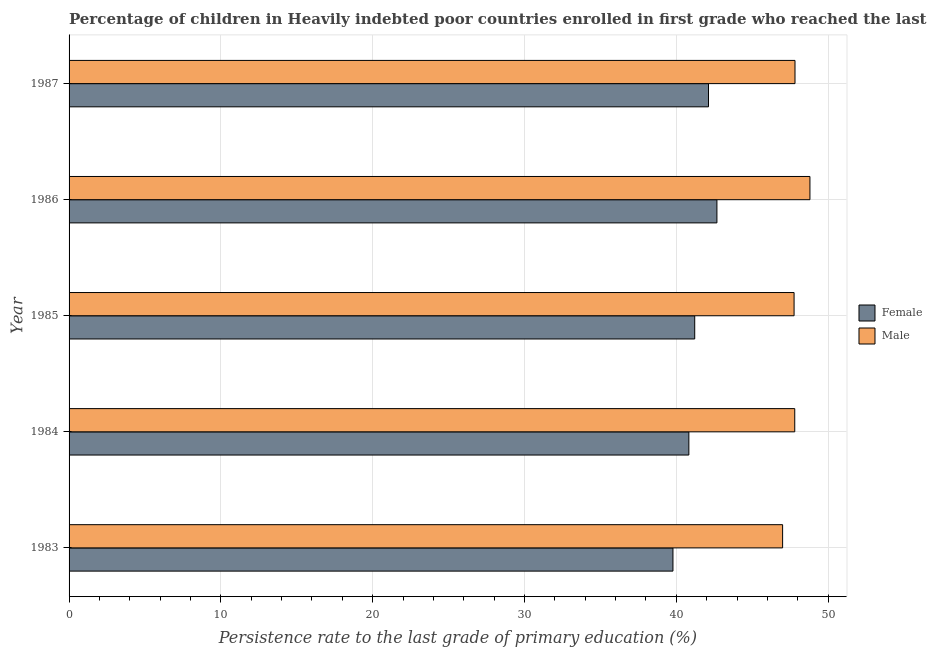How many different coloured bars are there?
Provide a short and direct response. 2. How many groups of bars are there?
Your answer should be very brief. 5. Are the number of bars per tick equal to the number of legend labels?
Your answer should be compact. Yes. Are the number of bars on each tick of the Y-axis equal?
Make the answer very short. Yes. How many bars are there on the 4th tick from the top?
Keep it short and to the point. 2. What is the label of the 3rd group of bars from the top?
Provide a short and direct response. 1985. What is the persistence rate of male students in 1987?
Ensure brevity in your answer.  47.82. Across all years, what is the maximum persistence rate of female students?
Provide a short and direct response. 42.68. Across all years, what is the minimum persistence rate of male students?
Provide a succinct answer. 47. In which year was the persistence rate of female students minimum?
Make the answer very short. 1983. What is the total persistence rate of male students in the graph?
Give a very brief answer. 239.19. What is the difference between the persistence rate of male students in 1984 and that in 1985?
Your response must be concise. 0.04. What is the difference between the persistence rate of female students in 1985 and the persistence rate of male students in 1984?
Your answer should be compact. -6.59. What is the average persistence rate of female students per year?
Provide a succinct answer. 41.32. In the year 1987, what is the difference between the persistence rate of female students and persistence rate of male students?
Your answer should be compact. -5.7. What is the ratio of the persistence rate of female students in 1983 to that in 1987?
Provide a short and direct response. 0.94. Is the difference between the persistence rate of male students in 1983 and 1986 greater than the difference between the persistence rate of female students in 1983 and 1986?
Provide a short and direct response. Yes. What is the difference between the highest and the second highest persistence rate of female students?
Provide a succinct answer. 0.56. What is the difference between the highest and the lowest persistence rate of male students?
Offer a terse response. 1.8. In how many years, is the persistence rate of female students greater than the average persistence rate of female students taken over all years?
Offer a terse response. 2. How many bars are there?
Offer a very short reply. 10. How many years are there in the graph?
Your answer should be compact. 5. What is the difference between two consecutive major ticks on the X-axis?
Provide a short and direct response. 10. Does the graph contain grids?
Give a very brief answer. Yes. How are the legend labels stacked?
Offer a very short reply. Vertical. What is the title of the graph?
Ensure brevity in your answer.  Percentage of children in Heavily indebted poor countries enrolled in first grade who reached the last grade of primary education. Does "Fertility rate" appear as one of the legend labels in the graph?
Offer a terse response. No. What is the label or title of the X-axis?
Make the answer very short. Persistence rate to the last grade of primary education (%). What is the label or title of the Y-axis?
Give a very brief answer. Year. What is the Persistence rate to the last grade of primary education (%) in Female in 1983?
Ensure brevity in your answer.  39.78. What is the Persistence rate to the last grade of primary education (%) of Male in 1983?
Your answer should be compact. 47. What is the Persistence rate to the last grade of primary education (%) in Female in 1984?
Offer a terse response. 40.83. What is the Persistence rate to the last grade of primary education (%) of Male in 1984?
Your answer should be very brief. 47.8. What is the Persistence rate to the last grade of primary education (%) in Female in 1985?
Make the answer very short. 41.21. What is the Persistence rate to the last grade of primary education (%) of Male in 1985?
Your response must be concise. 47.76. What is the Persistence rate to the last grade of primary education (%) in Female in 1986?
Offer a terse response. 42.68. What is the Persistence rate to the last grade of primary education (%) of Male in 1986?
Your answer should be very brief. 48.8. What is the Persistence rate to the last grade of primary education (%) in Female in 1987?
Your answer should be very brief. 42.12. What is the Persistence rate to the last grade of primary education (%) of Male in 1987?
Provide a short and direct response. 47.82. Across all years, what is the maximum Persistence rate to the last grade of primary education (%) of Female?
Your answer should be compact. 42.68. Across all years, what is the maximum Persistence rate to the last grade of primary education (%) in Male?
Keep it short and to the point. 48.8. Across all years, what is the minimum Persistence rate to the last grade of primary education (%) of Female?
Make the answer very short. 39.78. Across all years, what is the minimum Persistence rate to the last grade of primary education (%) of Male?
Provide a succinct answer. 47. What is the total Persistence rate to the last grade of primary education (%) in Female in the graph?
Your response must be concise. 206.62. What is the total Persistence rate to the last grade of primary education (%) in Male in the graph?
Your answer should be very brief. 239.19. What is the difference between the Persistence rate to the last grade of primary education (%) of Female in 1983 and that in 1984?
Your answer should be compact. -1.05. What is the difference between the Persistence rate to the last grade of primary education (%) in Male in 1983 and that in 1984?
Provide a short and direct response. -0.8. What is the difference between the Persistence rate to the last grade of primary education (%) in Female in 1983 and that in 1985?
Provide a succinct answer. -1.43. What is the difference between the Persistence rate to the last grade of primary education (%) of Male in 1983 and that in 1985?
Offer a terse response. -0.76. What is the difference between the Persistence rate to the last grade of primary education (%) of Female in 1983 and that in 1986?
Your response must be concise. -2.9. What is the difference between the Persistence rate to the last grade of primary education (%) in Female in 1983 and that in 1987?
Provide a short and direct response. -2.34. What is the difference between the Persistence rate to the last grade of primary education (%) in Male in 1983 and that in 1987?
Provide a succinct answer. -0.82. What is the difference between the Persistence rate to the last grade of primary education (%) of Female in 1984 and that in 1985?
Your response must be concise. -0.39. What is the difference between the Persistence rate to the last grade of primary education (%) of Male in 1984 and that in 1985?
Your answer should be compact. 0.04. What is the difference between the Persistence rate to the last grade of primary education (%) of Female in 1984 and that in 1986?
Your response must be concise. -1.85. What is the difference between the Persistence rate to the last grade of primary education (%) of Male in 1984 and that in 1986?
Offer a very short reply. -1. What is the difference between the Persistence rate to the last grade of primary education (%) in Female in 1984 and that in 1987?
Offer a terse response. -1.29. What is the difference between the Persistence rate to the last grade of primary education (%) in Male in 1984 and that in 1987?
Offer a very short reply. -0.02. What is the difference between the Persistence rate to the last grade of primary education (%) of Female in 1985 and that in 1986?
Give a very brief answer. -1.46. What is the difference between the Persistence rate to the last grade of primary education (%) in Male in 1985 and that in 1986?
Ensure brevity in your answer.  -1.04. What is the difference between the Persistence rate to the last grade of primary education (%) in Female in 1985 and that in 1987?
Keep it short and to the point. -0.91. What is the difference between the Persistence rate to the last grade of primary education (%) of Male in 1985 and that in 1987?
Your response must be concise. -0.06. What is the difference between the Persistence rate to the last grade of primary education (%) in Female in 1986 and that in 1987?
Offer a very short reply. 0.55. What is the difference between the Persistence rate to the last grade of primary education (%) of Male in 1986 and that in 1987?
Offer a very short reply. 0.98. What is the difference between the Persistence rate to the last grade of primary education (%) in Female in 1983 and the Persistence rate to the last grade of primary education (%) in Male in 1984?
Your response must be concise. -8.02. What is the difference between the Persistence rate to the last grade of primary education (%) in Female in 1983 and the Persistence rate to the last grade of primary education (%) in Male in 1985?
Offer a terse response. -7.98. What is the difference between the Persistence rate to the last grade of primary education (%) in Female in 1983 and the Persistence rate to the last grade of primary education (%) in Male in 1986?
Keep it short and to the point. -9.02. What is the difference between the Persistence rate to the last grade of primary education (%) in Female in 1983 and the Persistence rate to the last grade of primary education (%) in Male in 1987?
Offer a terse response. -8.04. What is the difference between the Persistence rate to the last grade of primary education (%) of Female in 1984 and the Persistence rate to the last grade of primary education (%) of Male in 1985?
Make the answer very short. -6.93. What is the difference between the Persistence rate to the last grade of primary education (%) in Female in 1984 and the Persistence rate to the last grade of primary education (%) in Male in 1986?
Provide a short and direct response. -7.98. What is the difference between the Persistence rate to the last grade of primary education (%) of Female in 1984 and the Persistence rate to the last grade of primary education (%) of Male in 1987?
Make the answer very short. -6.99. What is the difference between the Persistence rate to the last grade of primary education (%) in Female in 1985 and the Persistence rate to the last grade of primary education (%) in Male in 1986?
Provide a short and direct response. -7.59. What is the difference between the Persistence rate to the last grade of primary education (%) in Female in 1985 and the Persistence rate to the last grade of primary education (%) in Male in 1987?
Offer a very short reply. -6.61. What is the difference between the Persistence rate to the last grade of primary education (%) of Female in 1986 and the Persistence rate to the last grade of primary education (%) of Male in 1987?
Your response must be concise. -5.14. What is the average Persistence rate to the last grade of primary education (%) of Female per year?
Your answer should be very brief. 41.32. What is the average Persistence rate to the last grade of primary education (%) of Male per year?
Provide a short and direct response. 47.84. In the year 1983, what is the difference between the Persistence rate to the last grade of primary education (%) of Female and Persistence rate to the last grade of primary education (%) of Male?
Make the answer very short. -7.22. In the year 1984, what is the difference between the Persistence rate to the last grade of primary education (%) of Female and Persistence rate to the last grade of primary education (%) of Male?
Offer a terse response. -6.98. In the year 1985, what is the difference between the Persistence rate to the last grade of primary education (%) in Female and Persistence rate to the last grade of primary education (%) in Male?
Provide a succinct answer. -6.55. In the year 1986, what is the difference between the Persistence rate to the last grade of primary education (%) of Female and Persistence rate to the last grade of primary education (%) of Male?
Ensure brevity in your answer.  -6.13. In the year 1987, what is the difference between the Persistence rate to the last grade of primary education (%) in Female and Persistence rate to the last grade of primary education (%) in Male?
Provide a short and direct response. -5.7. What is the ratio of the Persistence rate to the last grade of primary education (%) of Female in 1983 to that in 1984?
Your response must be concise. 0.97. What is the ratio of the Persistence rate to the last grade of primary education (%) in Male in 1983 to that in 1984?
Keep it short and to the point. 0.98. What is the ratio of the Persistence rate to the last grade of primary education (%) in Female in 1983 to that in 1985?
Keep it short and to the point. 0.97. What is the ratio of the Persistence rate to the last grade of primary education (%) in Male in 1983 to that in 1985?
Give a very brief answer. 0.98. What is the ratio of the Persistence rate to the last grade of primary education (%) in Female in 1983 to that in 1986?
Offer a terse response. 0.93. What is the ratio of the Persistence rate to the last grade of primary education (%) of Male in 1983 to that in 1986?
Your answer should be very brief. 0.96. What is the ratio of the Persistence rate to the last grade of primary education (%) in Female in 1983 to that in 1987?
Ensure brevity in your answer.  0.94. What is the ratio of the Persistence rate to the last grade of primary education (%) in Male in 1983 to that in 1987?
Your answer should be very brief. 0.98. What is the ratio of the Persistence rate to the last grade of primary education (%) of Female in 1984 to that in 1985?
Give a very brief answer. 0.99. What is the ratio of the Persistence rate to the last grade of primary education (%) in Female in 1984 to that in 1986?
Offer a very short reply. 0.96. What is the ratio of the Persistence rate to the last grade of primary education (%) of Male in 1984 to that in 1986?
Your answer should be compact. 0.98. What is the ratio of the Persistence rate to the last grade of primary education (%) in Female in 1984 to that in 1987?
Provide a succinct answer. 0.97. What is the ratio of the Persistence rate to the last grade of primary education (%) of Male in 1984 to that in 1987?
Make the answer very short. 1. What is the ratio of the Persistence rate to the last grade of primary education (%) of Female in 1985 to that in 1986?
Ensure brevity in your answer.  0.97. What is the ratio of the Persistence rate to the last grade of primary education (%) in Male in 1985 to that in 1986?
Give a very brief answer. 0.98. What is the ratio of the Persistence rate to the last grade of primary education (%) in Female in 1985 to that in 1987?
Make the answer very short. 0.98. What is the ratio of the Persistence rate to the last grade of primary education (%) of Female in 1986 to that in 1987?
Keep it short and to the point. 1.01. What is the ratio of the Persistence rate to the last grade of primary education (%) of Male in 1986 to that in 1987?
Offer a very short reply. 1.02. What is the difference between the highest and the second highest Persistence rate to the last grade of primary education (%) in Female?
Give a very brief answer. 0.55. What is the difference between the highest and the second highest Persistence rate to the last grade of primary education (%) of Male?
Offer a very short reply. 0.98. What is the difference between the highest and the lowest Persistence rate to the last grade of primary education (%) in Female?
Offer a very short reply. 2.9. What is the difference between the highest and the lowest Persistence rate to the last grade of primary education (%) of Male?
Your response must be concise. 1.8. 